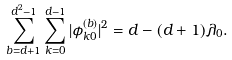Convert formula to latex. <formula><loc_0><loc_0><loc_500><loc_500>\sum _ { b = d + 1 } ^ { d ^ { 2 } - 1 } \sum _ { k = 0 } ^ { d - 1 } | \phi ^ { ( b ) } _ { k 0 } | ^ { 2 } = d - ( d + 1 ) \lambda _ { 0 } .</formula> 